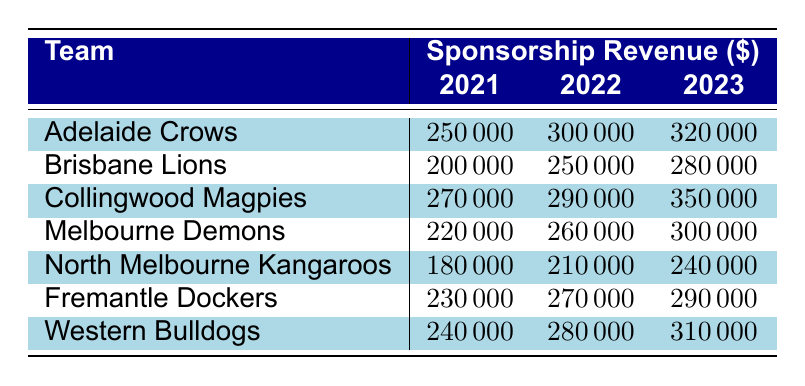What is the sponsorship revenue for the Adelaide Crows in 2022? The table shows that the sponsorship revenue for the Adelaide Crows in 2022 is listed directly under the 2022 column, which states 300000.
Answer: 300000 How much did the Brisbane Lions earn in sponsorship revenue in 2021? The table displays the Brisbane Lions' sponsorship revenue for 2021, which is directly available in the 2021 column, indicating it is 200000.
Answer: 200000 Which team had the highest sponsorship revenue in 2023? By comparing the values in the 2023 column for each team, the Collingwood Magpies have the highest revenue at 350000, surpassing the other teams listed.
Answer: Collingwood Magpies What is the average sponsorship revenue for North Melbourne Kangaroos across all three years? First, we sum the annual revenues for North Melbourne Kangaroos: 180000 (2021) + 210000 (2022) + 240000 (2023) = 630000. Next, we divide by the number of years (3), which gives us 630000 / 3 = 210000.
Answer: 210000 Did any team have a decrease in sponsorship revenue from 2021 to 2022? To determine if there was a decrease, we need to look at each team's revenue from 2021 to 2022. Upon examining the values, none of the teams saw a decrease; all teams showed an increase or stability in sponsorship revenue for that period.
Answer: No Which team increased their sponsorship revenue the most from 2021 to 2023? The change in sponsorship revenue from 2021 to 2023 needs to be calculated for each team. For example, Collingwood Magpies had an increase from 270000 to 350000 (an increase of 80000). After calculating the increases for all teams, Collingwood Magpies had the highest increase, making them the top team for growth during this period.
Answer: Collingwood Magpies What was the total sponsorship revenue for the Western Bulldogs over the years shown? We sum the sponsorship revenues by year: 240000 (2021) + 280000 (2022) + 310000 (2023) = 830000. This total represents the cumulative sponsorship revenue for the Western Bulldogs over the years listed.
Answer: 830000 How much did Fremantle Dockers make in sponsorship revenue in 2022 compared to 2023? The 2022 revenue for Fremantle Dockers is 270000 and for 2023 it is 290000. Comparing these, we see an increase of 20000 from 2022 to 2023. The comparison shows that 2023 revenue was higher.
Answer: Increased by 20000 What is the difference in sponsorship revenue between the team with the highest and the lowest revenue in 2021? The highest revenue in 2021 is from Collingwood Magpies at 270000, and the lowest is North Melbourne Kangaroos at 180000. The difference can be calculated as 270000 - 180000 = 90000. Thus, the revenue gap between the top and bottom teams is 90000.
Answer: 90000 